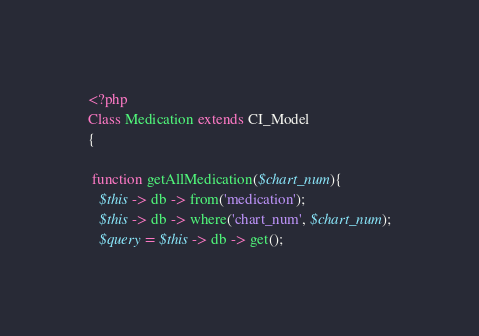<code> <loc_0><loc_0><loc_500><loc_500><_PHP_><?php
Class Medication extends CI_Model
{

 function getAllMedication($chart_num){
   $this -> db -> from('medication');
   $this -> db -> where('chart_num', $chart_num);
   $query = $this -> db -> get();</code> 